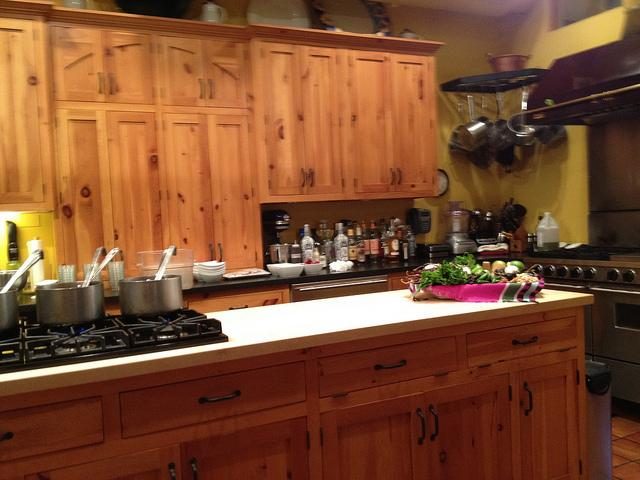What is the object called which is supporting the stove?

Choices:
A) cabinet
B) prep table
C) bar top
D) island island 